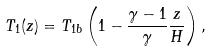Convert formula to latex. <formula><loc_0><loc_0><loc_500><loc_500>T _ { 1 } ( z ) = { T _ { 1 b } } \left ( 1 - \frac { \gamma - 1 } { \gamma } \frac { z } { H } \right ) ,</formula> 